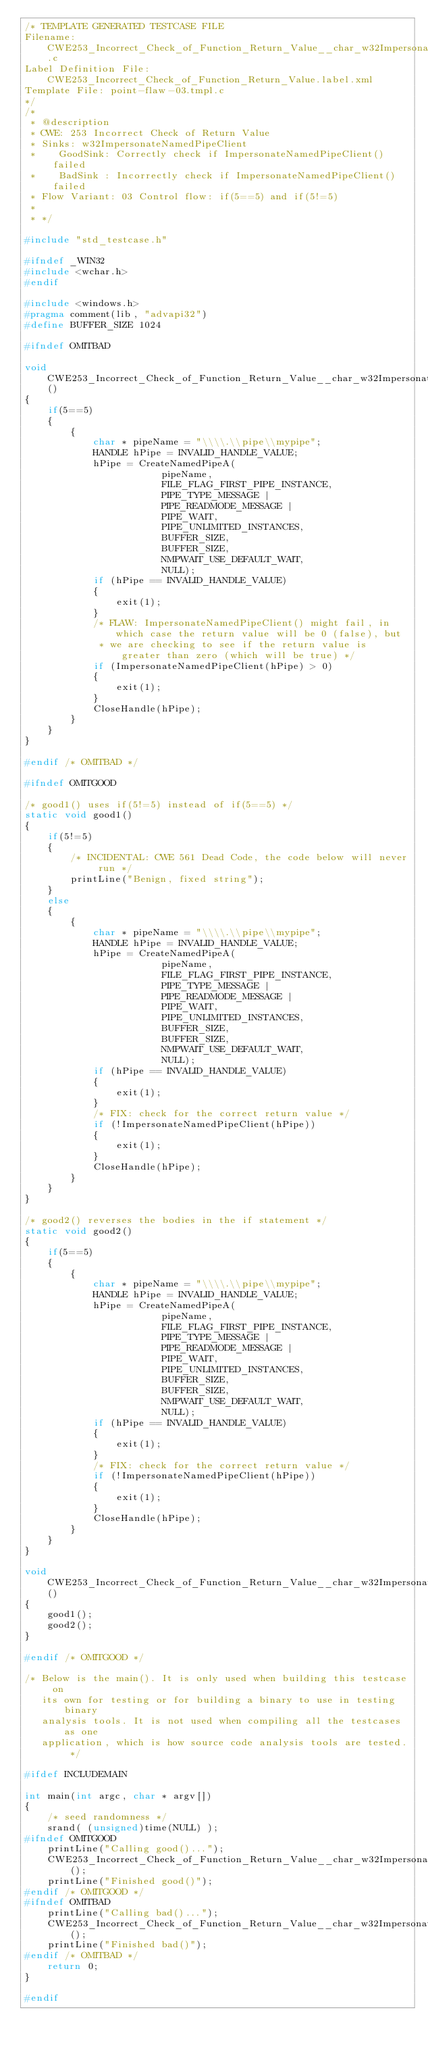<code> <loc_0><loc_0><loc_500><loc_500><_C_>/* TEMPLATE GENERATED TESTCASE FILE
Filename: CWE253_Incorrect_Check_of_Function_Return_Value__char_w32ImpersonateNamedPipeClient_03.c
Label Definition File: CWE253_Incorrect_Check_of_Function_Return_Value.label.xml
Template File: point-flaw-03.tmpl.c
*/
/*
 * @description
 * CWE: 253 Incorrect Check of Return Value
 * Sinks: w32ImpersonateNamedPipeClient
 *    GoodSink: Correctly check if ImpersonateNamedPipeClient() failed
 *    BadSink : Incorrectly check if ImpersonateNamedPipeClient() failed
 * Flow Variant: 03 Control flow: if(5==5) and if(5!=5)
 *
 * */

#include "std_testcase.h"

#ifndef _WIN32
#include <wchar.h>
#endif

#include <windows.h>
#pragma comment(lib, "advapi32")
#define BUFFER_SIZE 1024

#ifndef OMITBAD

void CWE253_Incorrect_Check_of_Function_Return_Value__char_w32ImpersonateNamedPipeClient_03_bad()
{
    if(5==5)
    {
        {
            char * pipeName = "\\\\.\\pipe\\mypipe";
            HANDLE hPipe = INVALID_HANDLE_VALUE;
            hPipe = CreateNamedPipeA(
                        pipeName,
                        FILE_FLAG_FIRST_PIPE_INSTANCE,
                        PIPE_TYPE_MESSAGE |
                        PIPE_READMODE_MESSAGE |
                        PIPE_WAIT,
                        PIPE_UNLIMITED_INSTANCES,
                        BUFFER_SIZE,
                        BUFFER_SIZE,
                        NMPWAIT_USE_DEFAULT_WAIT,
                        NULL);
            if (hPipe == INVALID_HANDLE_VALUE)
            {
                exit(1);
            }
            /* FLAW: ImpersonateNamedPipeClient() might fail, in which case the return value will be 0 (false), but
             * we are checking to see if the return value is greater than zero (which will be true) */
            if (ImpersonateNamedPipeClient(hPipe) > 0)
            {
                exit(1);
            }
            CloseHandle(hPipe);
        }
    }
}

#endif /* OMITBAD */

#ifndef OMITGOOD

/* good1() uses if(5!=5) instead of if(5==5) */
static void good1()
{
    if(5!=5)
    {
        /* INCIDENTAL: CWE 561 Dead Code, the code below will never run */
        printLine("Benign, fixed string");
    }
    else
    {
        {
            char * pipeName = "\\\\.\\pipe\\mypipe";
            HANDLE hPipe = INVALID_HANDLE_VALUE;
            hPipe = CreateNamedPipeA(
                        pipeName,
                        FILE_FLAG_FIRST_PIPE_INSTANCE,
                        PIPE_TYPE_MESSAGE |
                        PIPE_READMODE_MESSAGE |
                        PIPE_WAIT,
                        PIPE_UNLIMITED_INSTANCES,
                        BUFFER_SIZE,
                        BUFFER_SIZE,
                        NMPWAIT_USE_DEFAULT_WAIT,
                        NULL);
            if (hPipe == INVALID_HANDLE_VALUE)
            {
                exit(1);
            }
            /* FIX: check for the correct return value */
            if (!ImpersonateNamedPipeClient(hPipe))
            {
                exit(1);
            }
            CloseHandle(hPipe);
        }
    }
}

/* good2() reverses the bodies in the if statement */
static void good2()
{
    if(5==5)
    {
        {
            char * pipeName = "\\\\.\\pipe\\mypipe";
            HANDLE hPipe = INVALID_HANDLE_VALUE;
            hPipe = CreateNamedPipeA(
                        pipeName,
                        FILE_FLAG_FIRST_PIPE_INSTANCE,
                        PIPE_TYPE_MESSAGE |
                        PIPE_READMODE_MESSAGE |
                        PIPE_WAIT,
                        PIPE_UNLIMITED_INSTANCES,
                        BUFFER_SIZE,
                        BUFFER_SIZE,
                        NMPWAIT_USE_DEFAULT_WAIT,
                        NULL);
            if (hPipe == INVALID_HANDLE_VALUE)
            {
                exit(1);
            }
            /* FIX: check for the correct return value */
            if (!ImpersonateNamedPipeClient(hPipe))
            {
                exit(1);
            }
            CloseHandle(hPipe);
        }
    }
}

void CWE253_Incorrect_Check_of_Function_Return_Value__char_w32ImpersonateNamedPipeClient_03_good()
{
    good1();
    good2();
}

#endif /* OMITGOOD */

/* Below is the main(). It is only used when building this testcase on
   its own for testing or for building a binary to use in testing binary
   analysis tools. It is not used when compiling all the testcases as one
   application, which is how source code analysis tools are tested. */

#ifdef INCLUDEMAIN

int main(int argc, char * argv[])
{
    /* seed randomness */
    srand( (unsigned)time(NULL) );
#ifndef OMITGOOD
    printLine("Calling good()...");
    CWE253_Incorrect_Check_of_Function_Return_Value__char_w32ImpersonateNamedPipeClient_03_good();
    printLine("Finished good()");
#endif /* OMITGOOD */
#ifndef OMITBAD
    printLine("Calling bad()...");
    CWE253_Incorrect_Check_of_Function_Return_Value__char_w32ImpersonateNamedPipeClient_03_bad();
    printLine("Finished bad()");
#endif /* OMITBAD */
    return 0;
}

#endif
</code> 